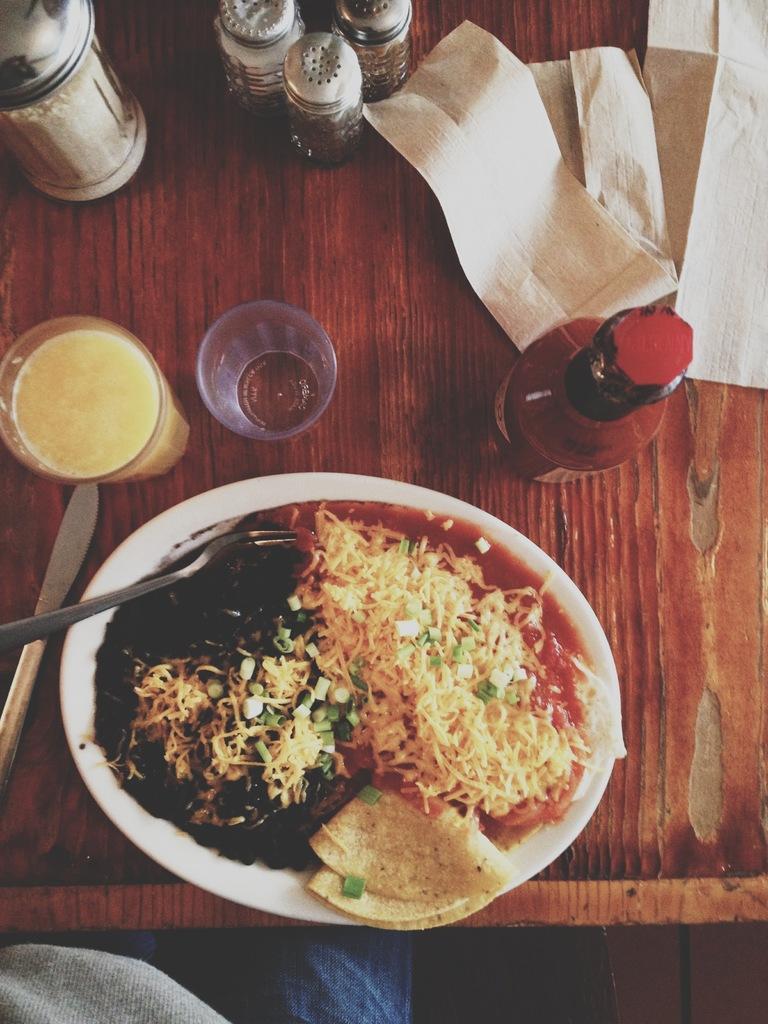Please provide a concise description of this image. In this image, we can see a brown color table, we can see a plate, there is some food on the plate, we can see glass and bottles on the table. 